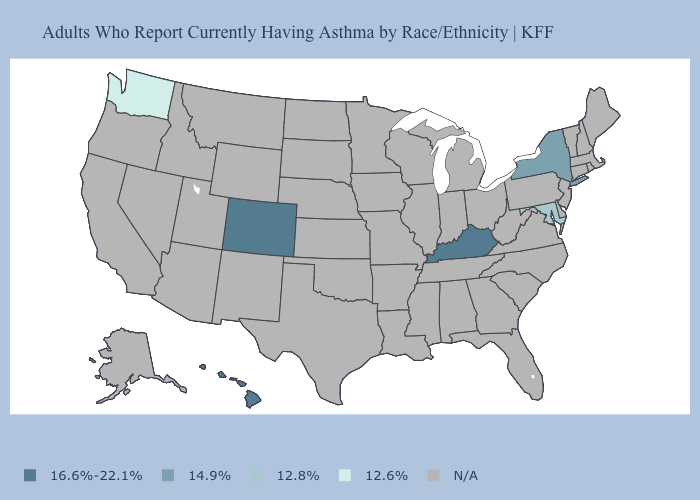Does Maryland have the lowest value in the South?
Short answer required. Yes. What is the value of Georgia?
Answer briefly. N/A. Does Maryland have the lowest value in the USA?
Answer briefly. No. Name the states that have a value in the range 16.6%-22.1%?
Write a very short answer. Colorado, Hawaii, Kentucky. Name the states that have a value in the range 12.6%?
Concise answer only. Washington. Is the legend a continuous bar?
Concise answer only. No. What is the value of Indiana?
Give a very brief answer. N/A. Does Colorado have the lowest value in the West?
Keep it brief. No. Name the states that have a value in the range 14.9%?
Short answer required. New York. What is the value of New Hampshire?
Be succinct. N/A. 